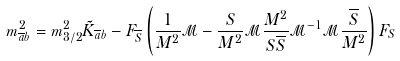Convert formula to latex. <formula><loc_0><loc_0><loc_500><loc_500>m ^ { 2 } _ { \overline { a } b } = m _ { 3 / 2 } ^ { 2 } \tilde { K } _ { \overline { a } b } - F _ { \overline { S } } \left ( \frac { 1 } { M ^ { 2 } } \mathcal { M } - \frac { S } { M ^ { 2 } } \mathcal { M } \frac { M ^ { 2 } } { S \overline { S } } \mathcal { M } ^ { - 1 } \mathcal { M } \frac { \overline { S } } { M ^ { 2 } } \right ) F _ { S }</formula> 